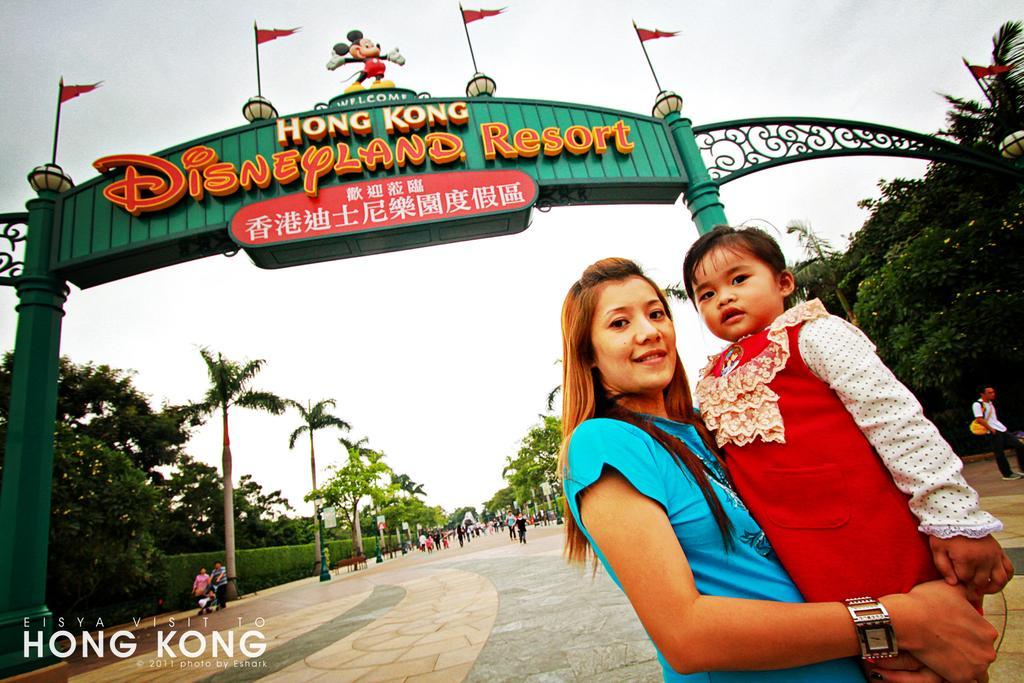Please provide a concise description of this image. In this picture we can see a woman carrying a baby in her hand on the right side. There is some text visible in the bottom left. We can see the text on a green object. We can see a toy and a few flags on this green object. There are a few trees visible on the right and left side of the image. 